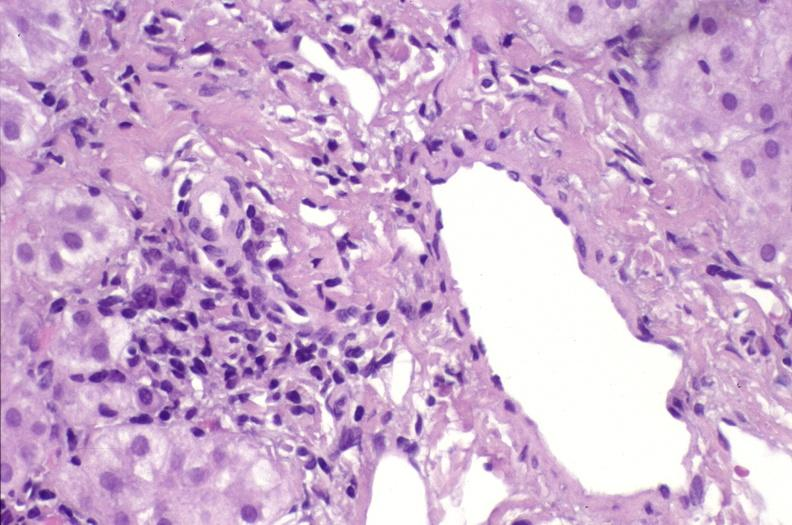s hepatobiliary present?
Answer the question using a single word or phrase. Yes 